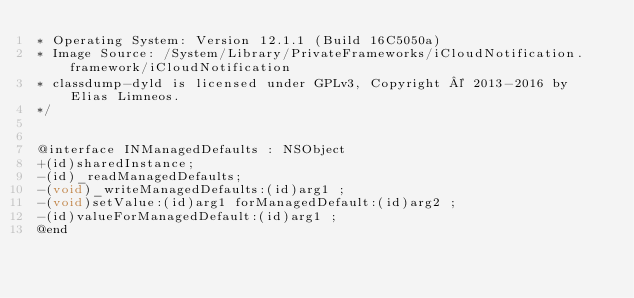Convert code to text. <code><loc_0><loc_0><loc_500><loc_500><_C_>* Operating System: Version 12.1.1 (Build 16C5050a)
* Image Source: /System/Library/PrivateFrameworks/iCloudNotification.framework/iCloudNotification
* classdump-dyld is licensed under GPLv3, Copyright © 2013-2016 by Elias Limneos.
*/


@interface INManagedDefaults : NSObject
+(id)sharedInstance;
-(id)_readManagedDefaults;
-(void)_writeManagedDefaults:(id)arg1 ;
-(void)setValue:(id)arg1 forManagedDefault:(id)arg2 ;
-(id)valueForManagedDefault:(id)arg1 ;
@end

</code> 